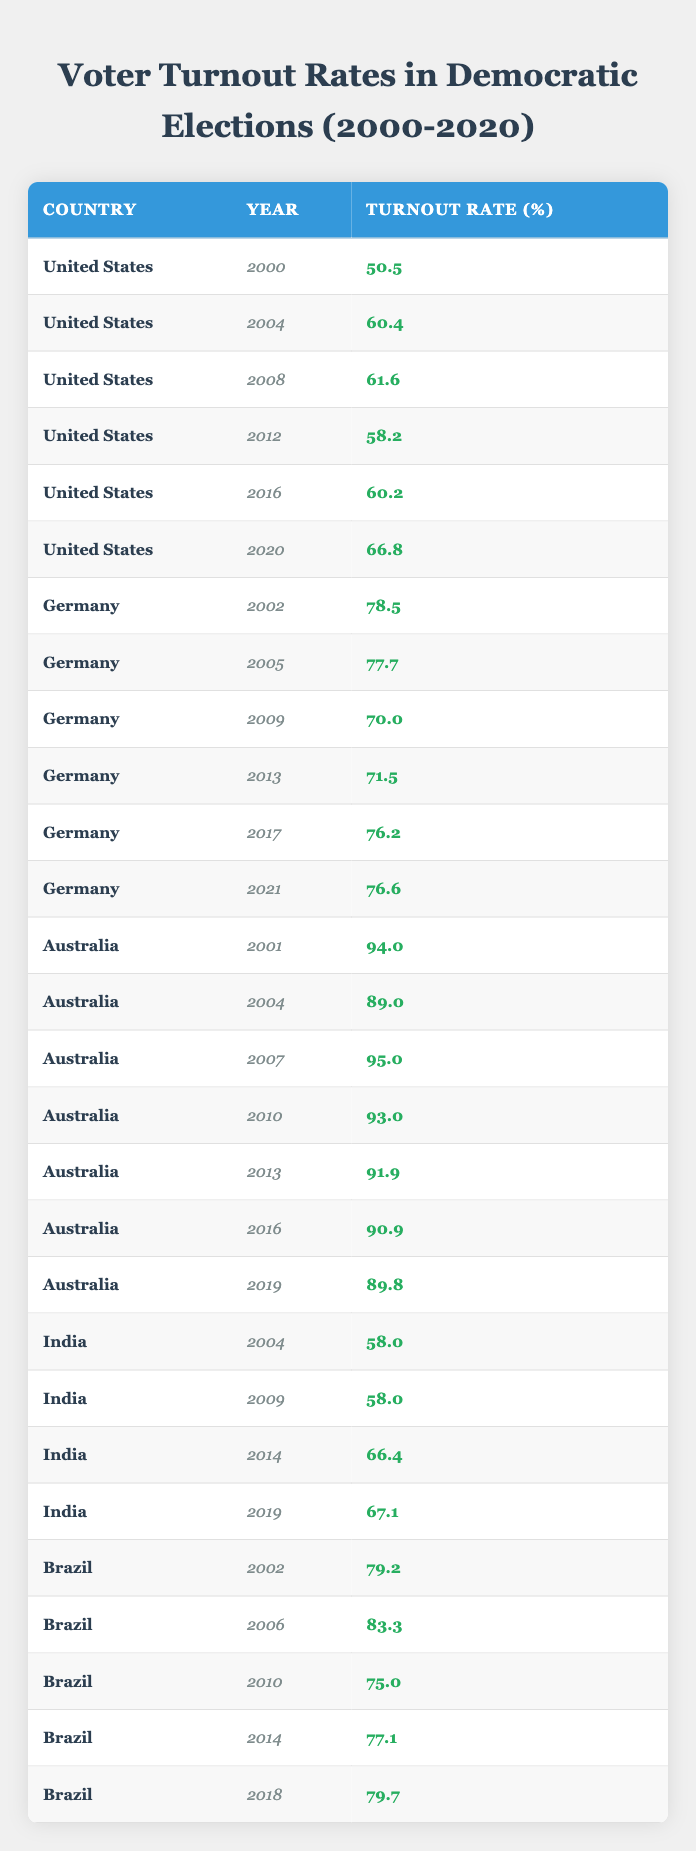What was the voter turnout rate in the United States in 2000? The table indicates the voter turnout rate for the United States in the year 2000 is listed directly. Looking at the row for the United States in 2000, the turnout rate is 50.5%.
Answer: 50.5% What was the highest voter turnout rate recorded for Australia between 2000 and 2020? To find the highest voter turnout rate for Australia, I review the rows related to Australia. The rates listed are 94.0%, 89.0%, 95.0%, 93.0%, 91.9%, 90.9%, and 89.8%. The highest of these is 95.0% in 2007.
Answer: 95.0% What was the trend in voter turnout rates for Germany from 2002 to 2021? Analyzing the data for Germany over the years shows the turnout rates were 78.5% in 2002, 77.7% in 2005, 70.0% in 2009, 71.5% in 2013, 76.2% in 2017, and 76.6% in 2021. The trend shows a decrease from 2002 to 2009, followed by a slight increase in the subsequent years.
Answer: Decrease and then slight increase Which country had the lowest voter turnout in elections from 2000 to 2020? The table shows that the lowest voter turnout rate among the listed countries is 50.5% for the United States in 2000.
Answer: United States in 2000 What was the average voter turnout rate for India over the years observed? The voter turnout rates for India in the years recorded are 58.0%, 58.0%, 66.4%, and 67.1%. To find the average, I sum these rates: (58.0 + 58.0 + 66.4 + 67.1) = 249.5. Dividing this by 4 gives an average of 62.375%.
Answer: 62.375% Did Brazil's voter turnout ever decrease year-on-year from 2002 to 2018? Observing the voter turnout rates for Brazil results in values of 79.2% in 2002, 83.3% in 2006, 75.0% in 2010, 77.1% in 2014, and 79.7% in 2018. The data shows that there was an overall increase from 2002 to 2006 but then a decrease from 2006 to 2010. Thus, there were year-on-year decreases.
Answer: Yes What can be inferred about voter engagement trends in the United States between 2000 and 2020? Examining the voter turnout rates for the United States shows an increase from 50.5% in 2000 to 66.8% in 2020, with fluctuations in some years, indicating an overall upward trend in voter engagement over the two decades.
Answer: Overall increase in engagement What was the difference in voter turnout rates in India between 2004 and 2019? The voter turnout rate for India in 2004 was 58.0%, and in 2019 it was 67.1%. The difference is calculated as 67.1% - 58.0% = 9.1%.
Answer: 9.1% Which year showed the highest turnout rate for Germany during the years observed? Reviewing the voter turnout rates for Germany (2002, 2005, 2009, 2013, 2017, 2021) indicates a maximum rate of 78.5% in 2002, which is the highest across the listed years.
Answer: 78.5% in 2002 What was the voter turnout trend for Australia in the years from 2001 to 2019? Analyzing the Australia data shows high turnout rates starting from 94.0% in 2001, with a peak of 95.0% in 2007, and declining slightly over the following years, finishing with 89.8% in 2019. This indicates a generally high turnout that decreased over time.
Answer: Generally high with slight decline 